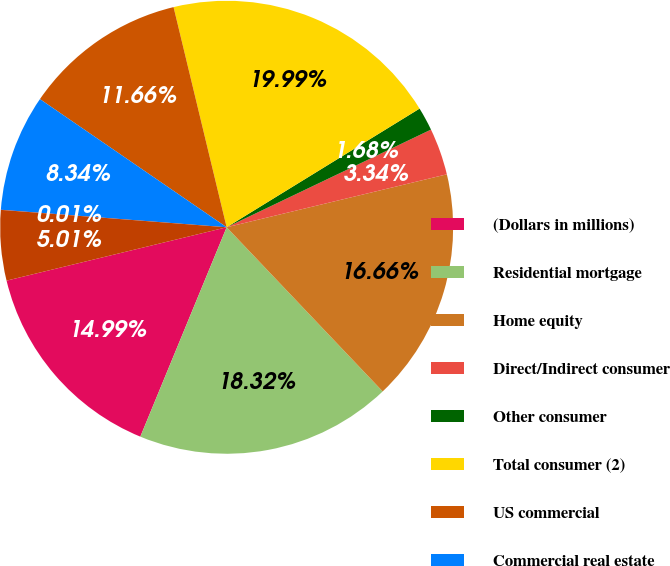<chart> <loc_0><loc_0><loc_500><loc_500><pie_chart><fcel>(Dollars in millions)<fcel>Residential mortgage<fcel>Home equity<fcel>Direct/Indirect consumer<fcel>Other consumer<fcel>Total consumer (2)<fcel>US commercial<fcel>Commercial real estate<fcel>Commercial lease financing<fcel>Non-US commercial<nl><fcel>14.99%<fcel>18.32%<fcel>16.66%<fcel>3.34%<fcel>1.68%<fcel>19.99%<fcel>11.66%<fcel>8.34%<fcel>0.01%<fcel>5.01%<nl></chart> 